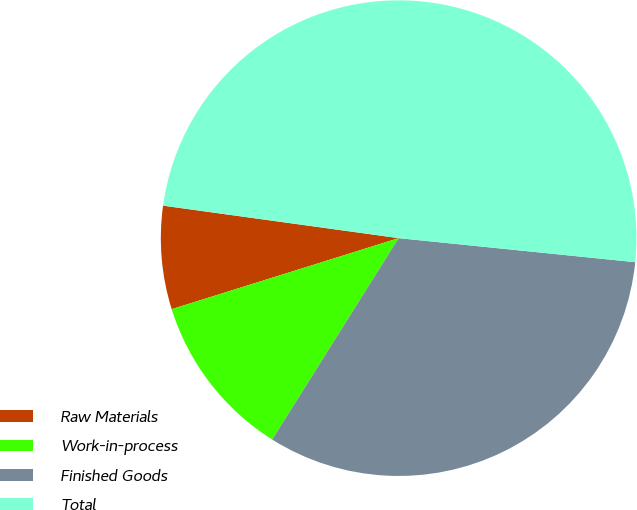Convert chart. <chart><loc_0><loc_0><loc_500><loc_500><pie_chart><fcel>Raw Materials<fcel>Work-in-process<fcel>Finished Goods<fcel>Total<nl><fcel>7.01%<fcel>11.25%<fcel>32.31%<fcel>49.43%<nl></chart> 